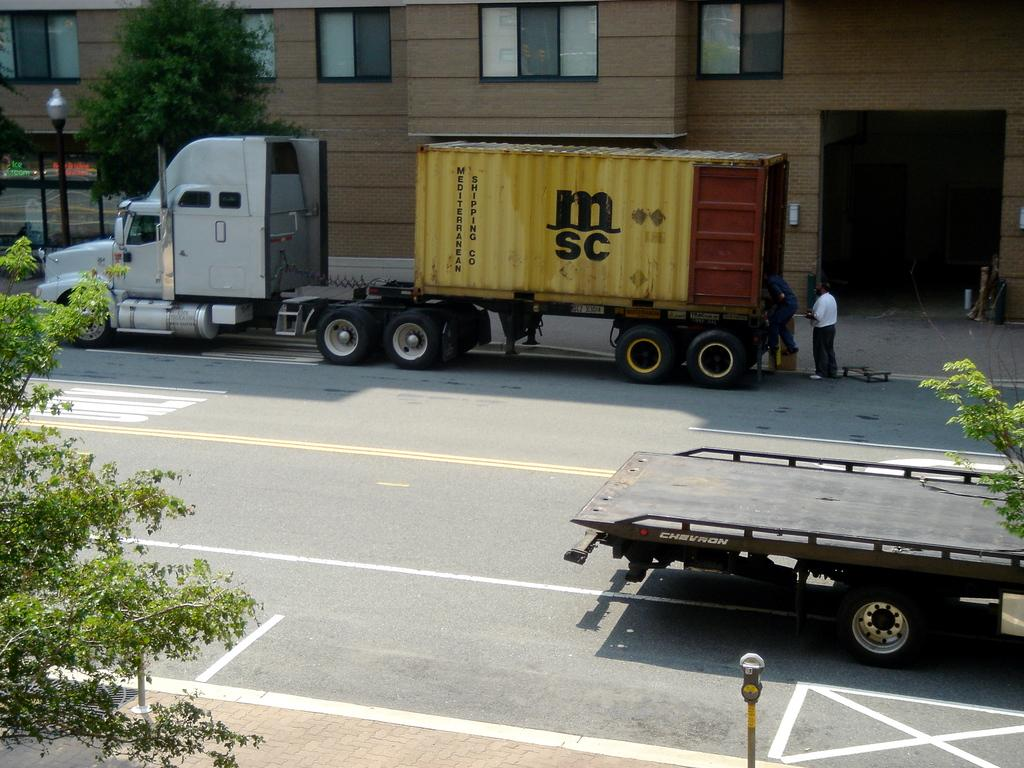What can be seen in the foreground of the picture? In the foreground of the picture, there are trees, a footpath, and a road. What is happening on the road? There are trucks on the road. Can you describe the background of the picture? In the background of the picture, there are people, a footpath, trees, poles, and buildings. Are your friends visible in the picture, and are they interacting with the bears? There are no friends or bears present in the image. 